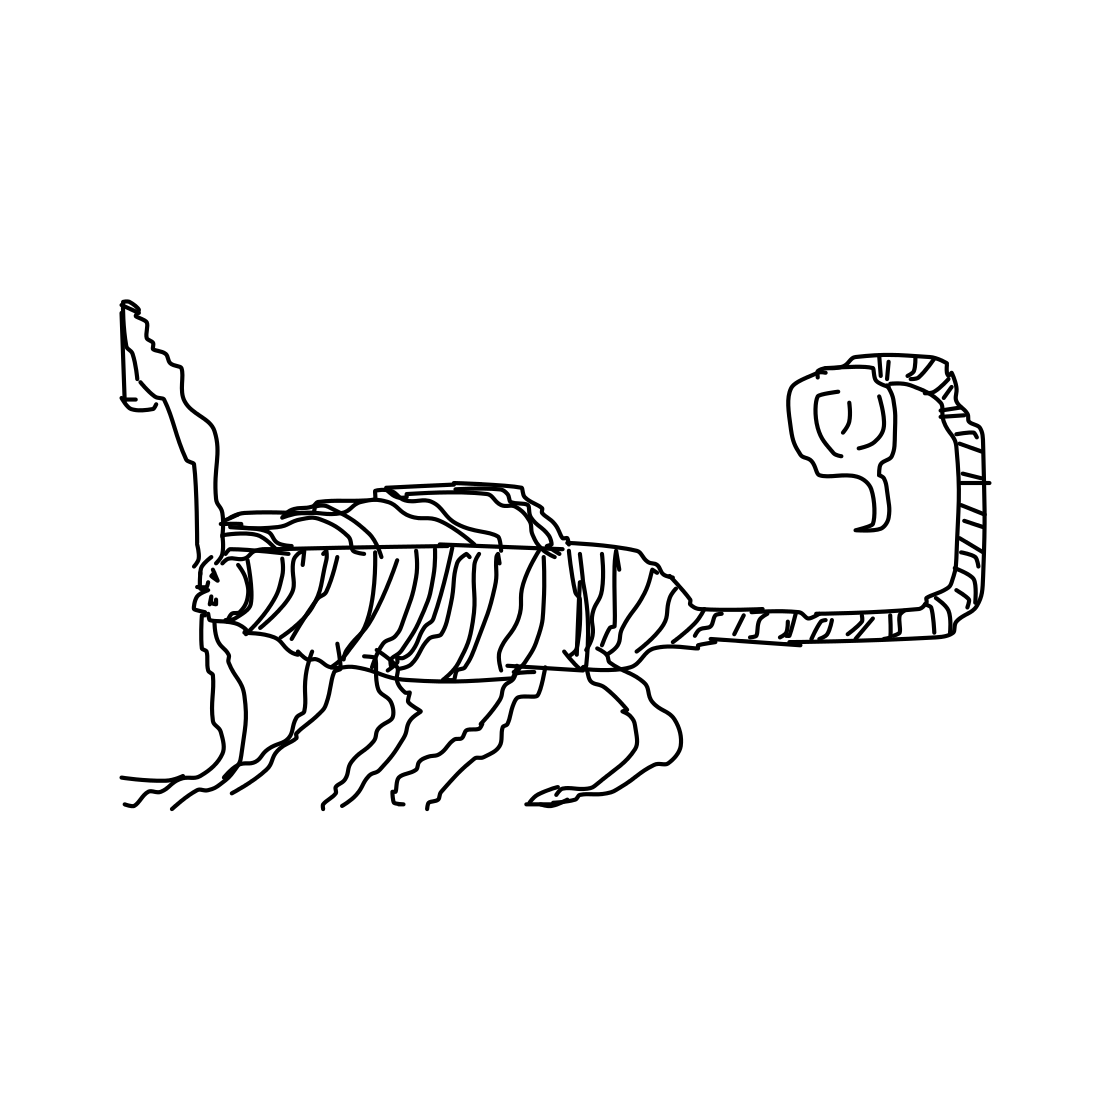Is there a sketchy squirrel in the picture? No 